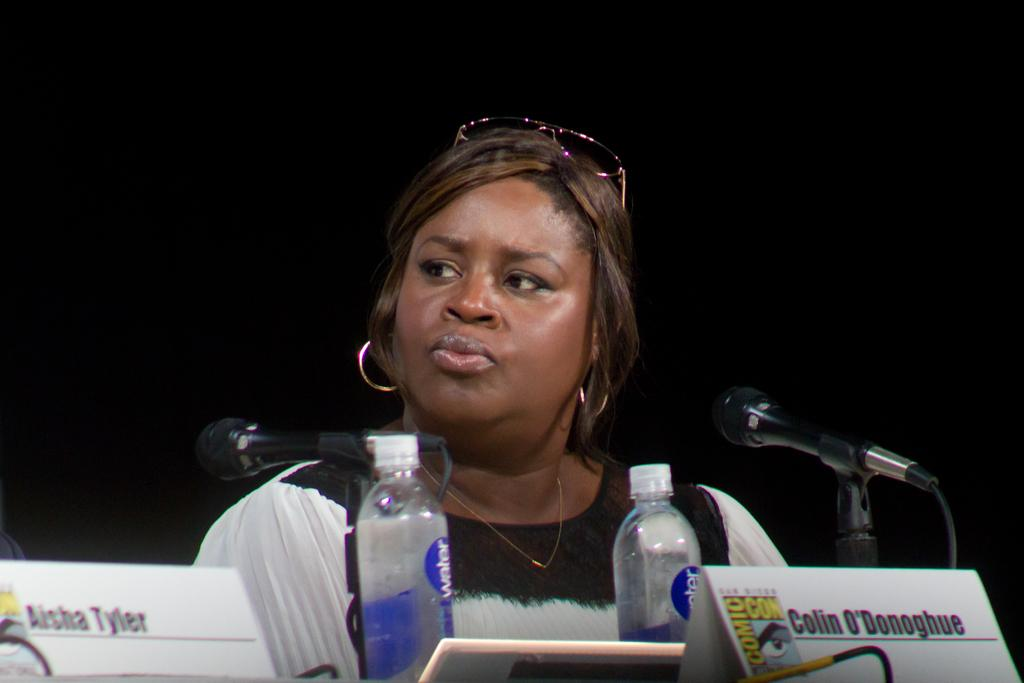Who is present in the image? There is a woman in the image. What is the woman wearing on her head? The woman has goggles on her head. What objects can be seen in the image besides the woman? There are bottles, a microphone, and name boards in the image. What type of machine is being controlled by the woman's impulse in the image? There is no machine present in the image, nor is there any indication of the woman's impulses affecting any object or device. 